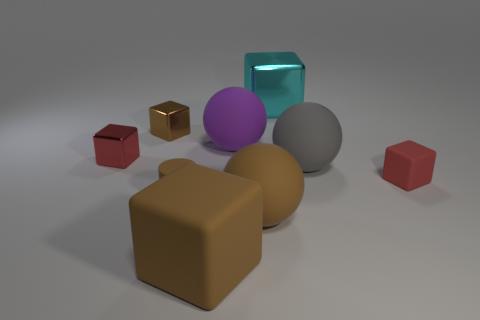There is a brown thing that is behind the small brown cylinder; how big is it?
Offer a terse response. Small. There is a small cube that is on the right side of the purple rubber object; how many tiny objects are behind it?
Your answer should be compact. 2. How many other objects are the same size as the brown sphere?
Keep it short and to the point. 4. Is the cylinder the same color as the large rubber block?
Your answer should be very brief. Yes. There is a red thing to the right of the small brown cylinder; does it have the same shape as the large metal thing?
Give a very brief answer. Yes. How many blocks are both right of the brown rubber sphere and in front of the large metallic cube?
Make the answer very short. 1. What material is the gray sphere?
Offer a very short reply. Rubber. Are there any other things that have the same color as the large rubber cube?
Offer a very short reply. Yes. Are the big brown ball and the large cyan cube made of the same material?
Your answer should be very brief. No. How many small brown blocks are behind the small red block on the right side of the small brown thing that is in front of the tiny brown metallic thing?
Offer a terse response. 1. 